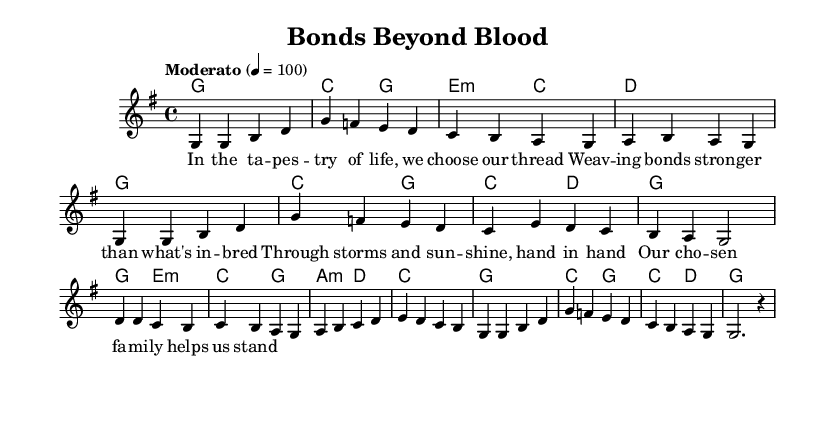What is the key signature of this music? The key signature is determined by looking at the key indicated in the global section of the code. It states "g \major," which means the key has one sharp (F#).
Answer: G major What is the time signature of this music? The time signature can be identified in the global section, where it is specified as "4/4." This means there are four beats in a measure and a quarter note gets one beat.
Answer: 4/4 What is the tempo marking for this piece? The tempo marking is indicated in the global section as "Moderato," which typically means a moderate tempo, alongside the specific beats per minute shown as "4 = 100."
Answer: Moderato Which chords are used in the first verse? The chords for the first verse can be identified from the harmonies section and match the melody. They are G major, C major, E minor, and D major, aligned with how common folk tunes often create a supportive harmonic texture.
Answer: G, C, E minor, D What is the main theme celebrated in this folk tune? By analyzing the lyrics, which discuss the strength of chosen families and support systems, the theme conveys a message about relationships and bonds formed outside of biological ties, reflecting on resilience amid life’s challenges.
Answer: Chosen families 